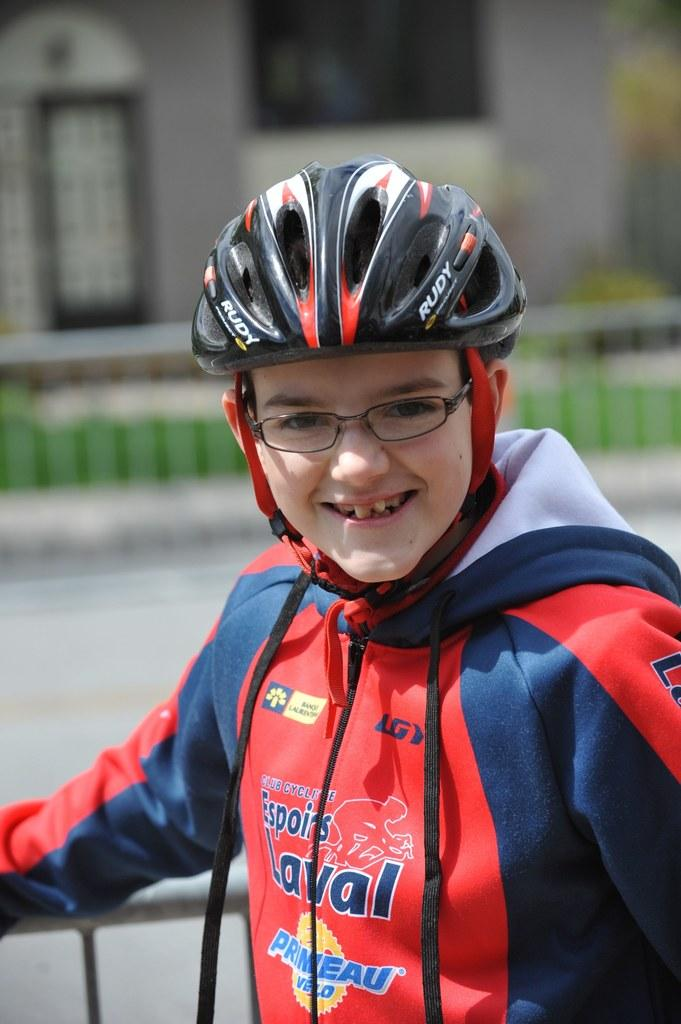Who is in the image? There is a boy in the image. What is the boy doing in the image? The boy is smiling in the image. What is the boy wearing in the image? The boy is wearing a helmet in the image. Can you describe the background of the image? The background of the image is blurred, but there is a building, grass, and a fence visible. How many people are in the group in the image? There is no group present in the image; it features a single boy. What type of knot is the boy tying in the image? There is no knot-tying activity depicted in the image; the boy is wearing a helmet and smiling. 